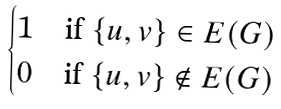Convert formula to latex. <formula><loc_0><loc_0><loc_500><loc_500>\begin{cases} 1 \quad \text {if } \{ u , v \} \in E ( G ) \\ 0 \quad \text {if } \{ u , v \} \notin E ( G ) \end{cases}</formula> 